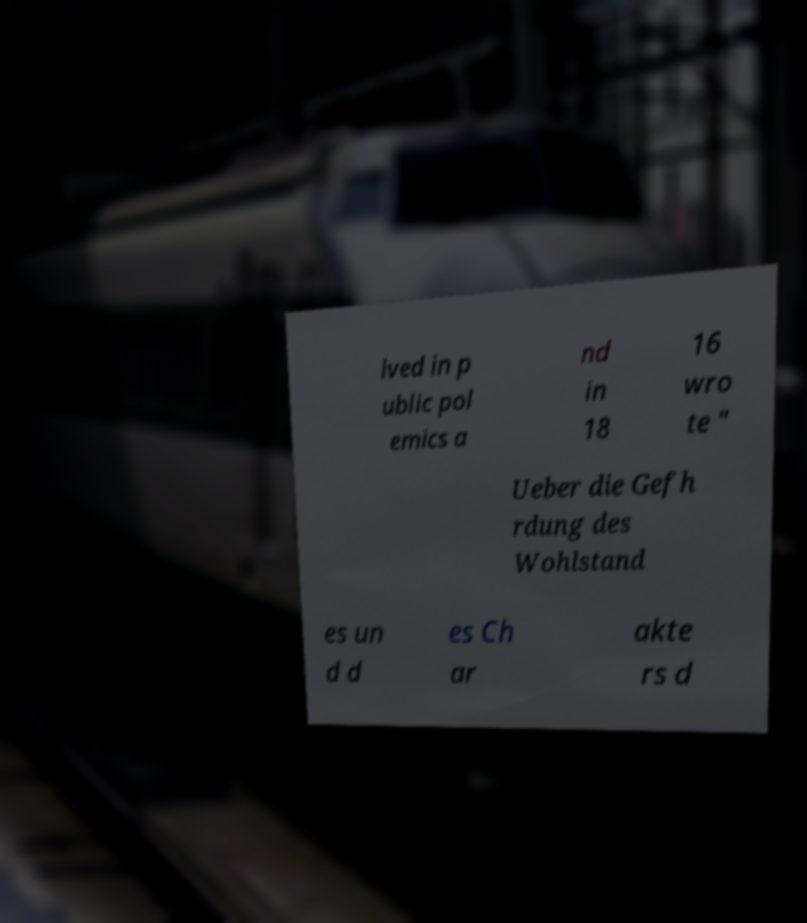What messages or text are displayed in this image? I need them in a readable, typed format. lved in p ublic pol emics a nd in 18 16 wro te " Ueber die Gefh rdung des Wohlstand es un d d es Ch ar akte rs d 